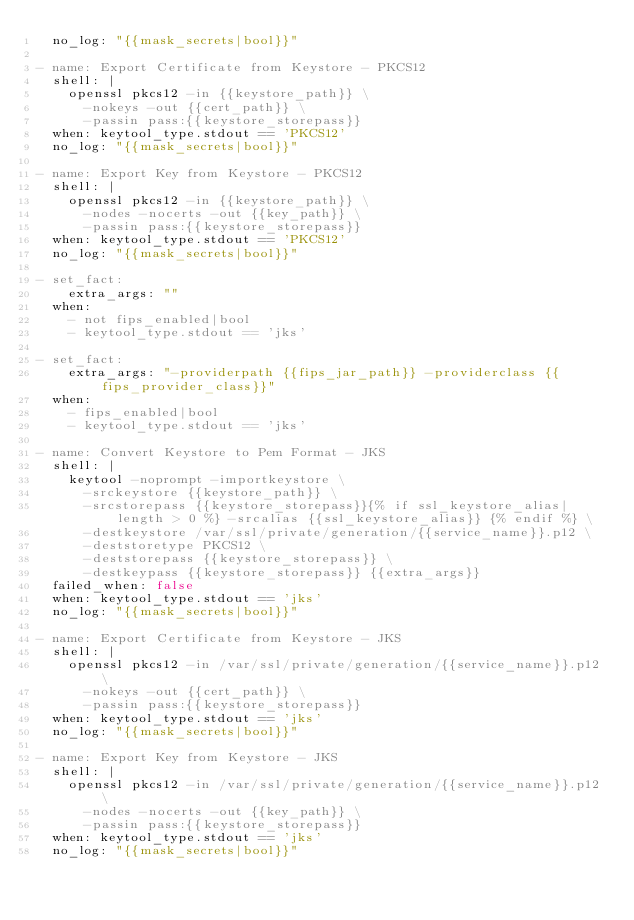Convert code to text. <code><loc_0><loc_0><loc_500><loc_500><_YAML_>  no_log: "{{mask_secrets|bool}}"

- name: Export Certificate from Keystore - PKCS12
  shell: |
    openssl pkcs12 -in {{keystore_path}} \
      -nokeys -out {{cert_path}} \
      -passin pass:{{keystore_storepass}}
  when: keytool_type.stdout == 'PKCS12'
  no_log: "{{mask_secrets|bool}}"

- name: Export Key from Keystore - PKCS12
  shell: |
    openssl pkcs12 -in {{keystore_path}} \
      -nodes -nocerts -out {{key_path}} \
      -passin pass:{{keystore_storepass}}
  when: keytool_type.stdout == 'PKCS12'
  no_log: "{{mask_secrets|bool}}"

- set_fact:
    extra_args: ""
  when:
    - not fips_enabled|bool
    - keytool_type.stdout == 'jks'

- set_fact:
    extra_args: "-providerpath {{fips_jar_path}} -providerclass {{fips_provider_class}}"
  when:
    - fips_enabled|bool
    - keytool_type.stdout == 'jks'

- name: Convert Keystore to Pem Format - JKS
  shell: |
    keytool -noprompt -importkeystore \
      -srckeystore {{keystore_path}} \
      -srcstorepass {{keystore_storepass}}{% if ssl_keystore_alias|length > 0 %} -srcalias {{ssl_keystore_alias}} {% endif %} \
      -destkeystore /var/ssl/private/generation/{{service_name}}.p12 \
      -deststoretype PKCS12 \
      -deststorepass {{keystore_storepass}} \
      -destkeypass {{keystore_storepass}} {{extra_args}}
  failed_when: false
  when: keytool_type.stdout == 'jks'
  no_log: "{{mask_secrets|bool}}"

- name: Export Certificate from Keystore - JKS
  shell: |
    openssl pkcs12 -in /var/ssl/private/generation/{{service_name}}.p12 \
      -nokeys -out {{cert_path}} \
      -passin pass:{{keystore_storepass}}
  when: keytool_type.stdout == 'jks'
  no_log: "{{mask_secrets|bool}}"

- name: Export Key from Keystore - JKS
  shell: |
    openssl pkcs12 -in /var/ssl/private/generation/{{service_name}}.p12 \
      -nodes -nocerts -out {{key_path}} \
      -passin pass:{{keystore_storepass}}
  when: keytool_type.stdout == 'jks'
  no_log: "{{mask_secrets|bool}}"
</code> 